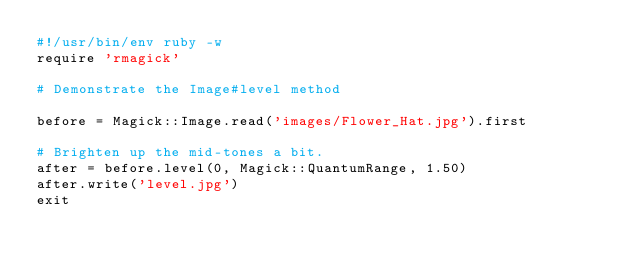Convert code to text. <code><loc_0><loc_0><loc_500><loc_500><_Ruby_>#!/usr/bin/env ruby -w
require 'rmagick'

# Demonstrate the Image#level method

before = Magick::Image.read('images/Flower_Hat.jpg').first

# Brighten up the mid-tones a bit.
after = before.level(0, Magick::QuantumRange, 1.50)
after.write('level.jpg')
exit
</code> 